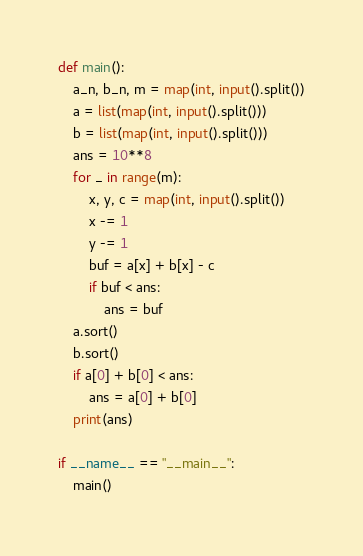Convert code to text. <code><loc_0><loc_0><loc_500><loc_500><_Python_>def main():
    a_n, b_n, m = map(int, input().split())
    a = list(map(int, input().split()))
    b = list(map(int, input().split()))
    ans = 10**8
    for _ in range(m):
        x, y, c = map(int, input().split())
        x -= 1
        y -= 1
        buf = a[x] + b[x] - c
        if buf < ans:
            ans = buf
    a.sort()
    b.sort()
    if a[0] + b[0] < ans:
        ans = a[0] + b[0]
    print(ans)

if __name__ == "__main__":
    main()</code> 